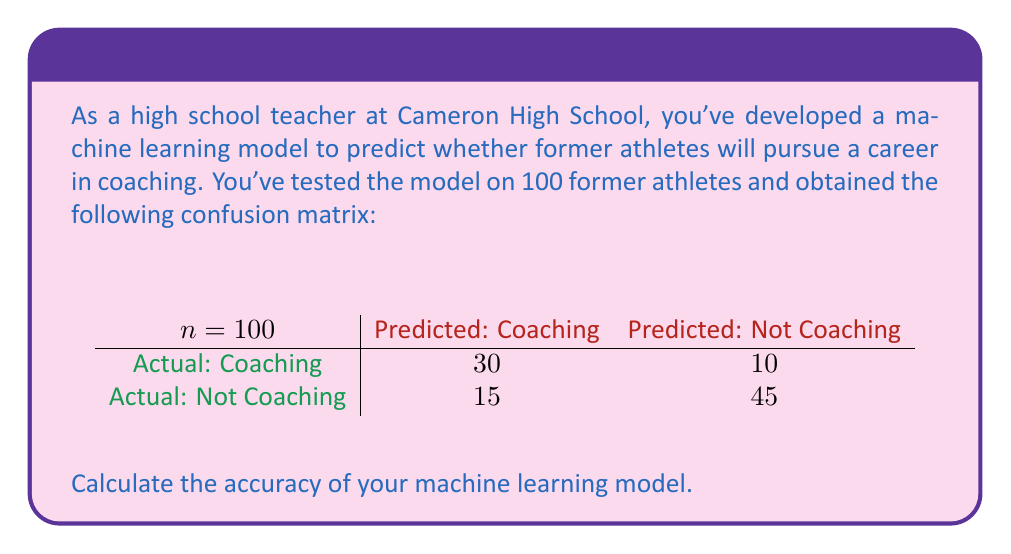Can you answer this question? To calculate the accuracy of a machine learning model using a confusion matrix, we need to follow these steps:

1. Understand the confusion matrix:
   - True Positives (TP): 30 (correctly predicted coaching)
   - False Negatives (FN): 10 (incorrectly predicted not coaching)
   - False Positives (FP): 15 (incorrectly predicted coaching)
   - True Negatives (TN): 45 (correctly predicted not coaching)

2. Calculate the total number of predictions:
   $\text{Total} = \text{TP} + \text{FN} + \text{FP} + \text{TN}$
   $\text{Total} = 30 + 10 + 15 + 45 = 100$

3. Calculate the number of correct predictions:
   $\text{Correct Predictions} = \text{TP} + \text{TN}$
   $\text{Correct Predictions} = 30 + 45 = 75$

4. Calculate the accuracy using the formula:
   $$\text{Accuracy} = \frac{\text{Correct Predictions}}{\text{Total Predictions}}$$

5. Substitute the values:
   $$\text{Accuracy} = \frac{75}{100} = 0.75$$

6. Convert to percentage:
   $$\text{Accuracy} = 0.75 \times 100\% = 75\%$$

Therefore, the accuracy of your machine learning model is 75%.
Answer: 75% 